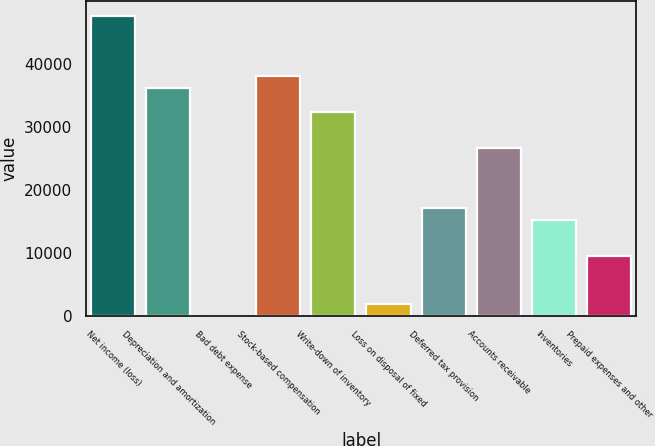Convert chart. <chart><loc_0><loc_0><loc_500><loc_500><bar_chart><fcel>Net income (loss)<fcel>Depreciation and amortization<fcel>Bad debt expense<fcel>Stock-based compensation<fcel>Write-down of inventory<fcel>Loss on disposal of fixed<fcel>Deferred tax provision<fcel>Accounts receivable<fcel>Inventories<fcel>Prepaid expenses and other<nl><fcel>47527<fcel>36125.8<fcel>22<fcel>38026<fcel>32325.4<fcel>1922.2<fcel>17123.8<fcel>26624.8<fcel>15223.6<fcel>9523<nl></chart> 